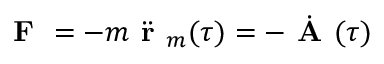<formula> <loc_0><loc_0><loc_500><loc_500>F = - m \ D d o t { r } _ { m } ( \tau ) = - \dot { A } ( \tau )</formula> 